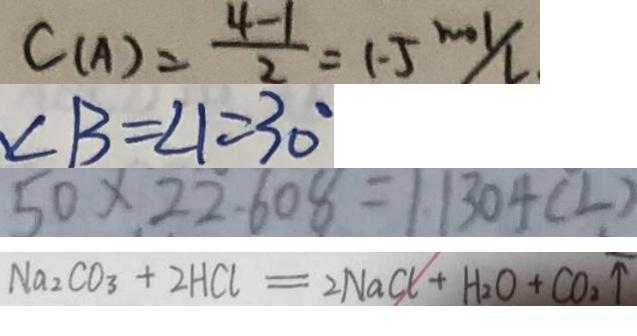Convert formula to latex. <formula><loc_0><loc_0><loc_500><loc_500>C ( A ) = \frac { 4 - 1 } { 2 } = 1 . 5 m o l / L 
 \angle B = \angle 1 = 3 0 ^ { \circ } 
 5 0 \times 2 2 . 6 0 8 = 1 . 1 3 0 4 ( L ) 
 N a _ { 2 } C O _ { 3 } + 2 H C l = 2 N a C l + H _ { 2 } O + C O _ { 2 } \uparrow</formula> 